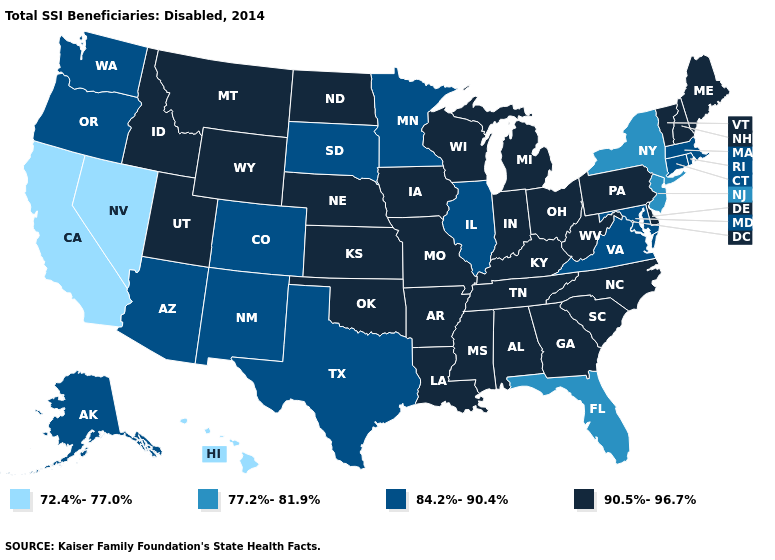What is the value of Kentucky?
Quick response, please. 90.5%-96.7%. What is the value of North Dakota?
Concise answer only. 90.5%-96.7%. Does California have a higher value than Vermont?
Quick response, please. No. What is the lowest value in the USA?
Concise answer only. 72.4%-77.0%. Which states hav the highest value in the South?
Give a very brief answer. Alabama, Arkansas, Delaware, Georgia, Kentucky, Louisiana, Mississippi, North Carolina, Oklahoma, South Carolina, Tennessee, West Virginia. What is the highest value in the Northeast ?
Concise answer only. 90.5%-96.7%. What is the value of Florida?
Quick response, please. 77.2%-81.9%. What is the highest value in states that border West Virginia?
Keep it brief. 90.5%-96.7%. What is the value of Wisconsin?
Be succinct. 90.5%-96.7%. Name the states that have a value in the range 84.2%-90.4%?
Quick response, please. Alaska, Arizona, Colorado, Connecticut, Illinois, Maryland, Massachusetts, Minnesota, New Mexico, Oregon, Rhode Island, South Dakota, Texas, Virginia, Washington. What is the value of North Carolina?
Give a very brief answer. 90.5%-96.7%. What is the highest value in states that border Arizona?
Keep it brief. 90.5%-96.7%. Does Maryland have the lowest value in the USA?
Give a very brief answer. No. What is the highest value in the West ?
Write a very short answer. 90.5%-96.7%. 